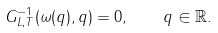<formula> <loc_0><loc_0><loc_500><loc_500>G _ { L , T } ^ { - 1 } ( \omega ( q ) , q ) = 0 , \quad q \in { \mathbb { R } } .</formula> 